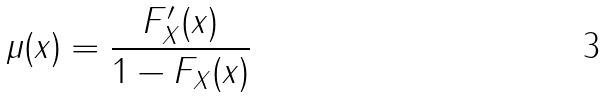<formula> <loc_0><loc_0><loc_500><loc_500>\mu ( x ) = \frac { F _ { X } ^ { \prime } ( x ) } { 1 - F _ { X } ( x ) }</formula> 